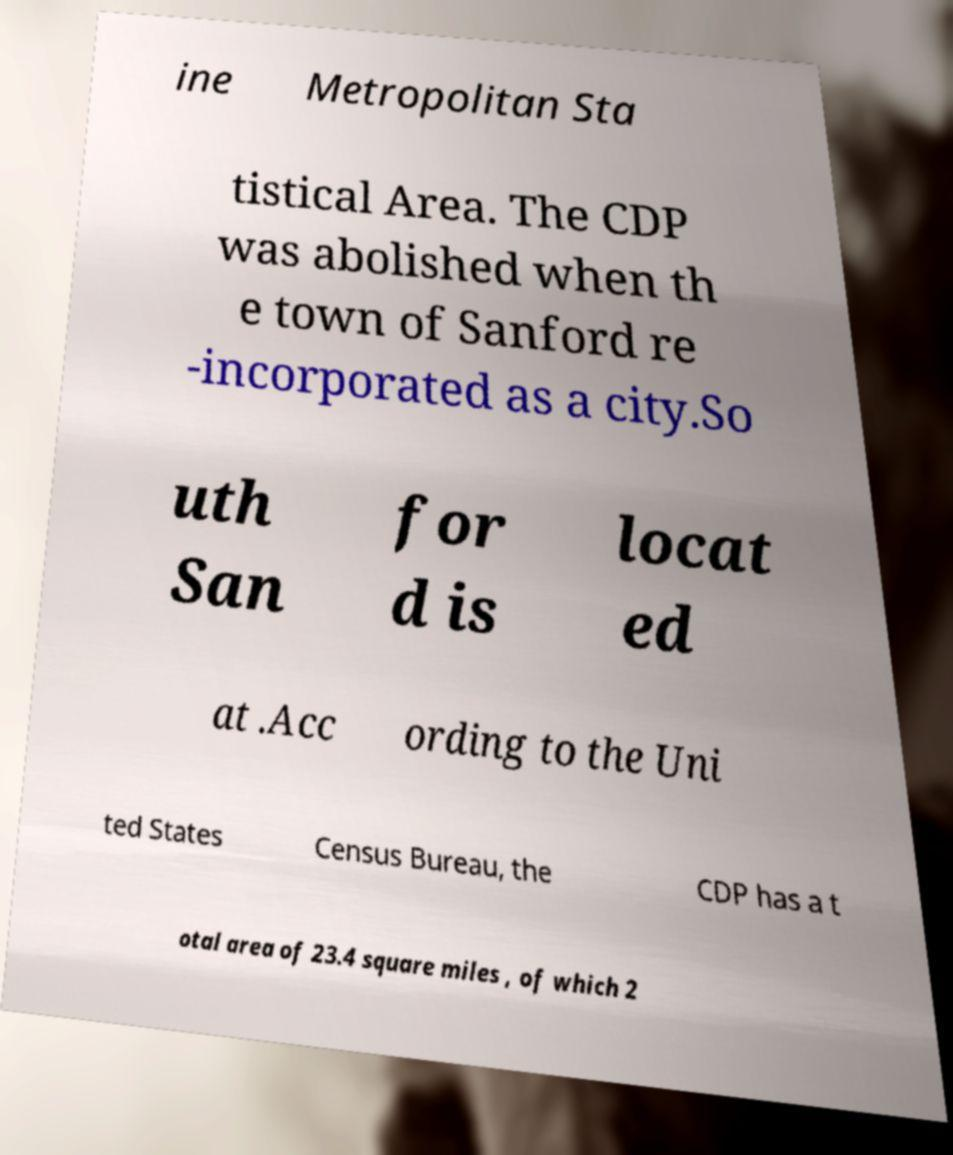Can you accurately transcribe the text from the provided image for me? ine Metropolitan Sta tistical Area. The CDP was abolished when th e town of Sanford re -incorporated as a city.So uth San for d is locat ed at .Acc ording to the Uni ted States Census Bureau, the CDP has a t otal area of 23.4 square miles , of which 2 